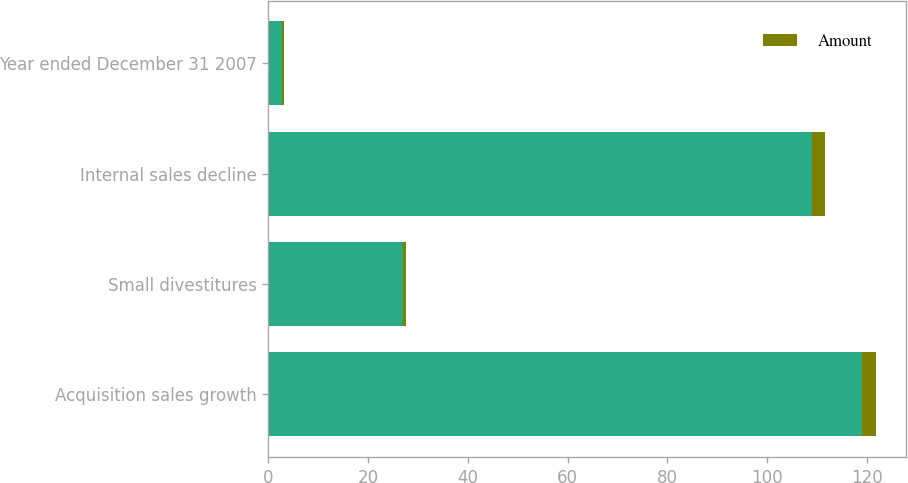Convert chart to OTSL. <chart><loc_0><loc_0><loc_500><loc_500><stacked_bar_chart><ecel><fcel>Acquisition sales growth<fcel>Small divestitures<fcel>Internal sales decline<fcel>Year ended December 31 2007<nl><fcel>nan<fcel>119<fcel>27<fcel>109<fcel>2.8<nl><fcel>Amount<fcel>2.8<fcel>0.6<fcel>2.6<fcel>0.4<nl></chart> 